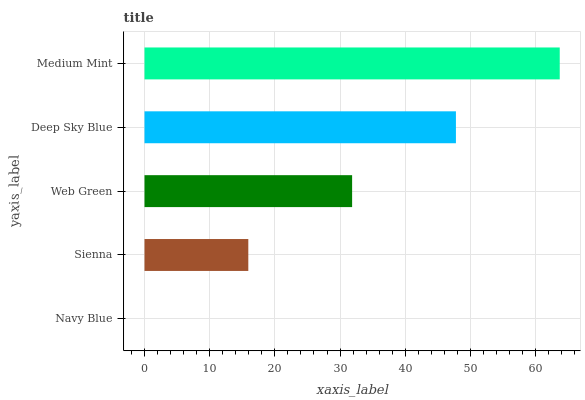Is Navy Blue the minimum?
Answer yes or no. Yes. Is Medium Mint the maximum?
Answer yes or no. Yes. Is Sienna the minimum?
Answer yes or no. No. Is Sienna the maximum?
Answer yes or no. No. Is Sienna greater than Navy Blue?
Answer yes or no. Yes. Is Navy Blue less than Sienna?
Answer yes or no. Yes. Is Navy Blue greater than Sienna?
Answer yes or no. No. Is Sienna less than Navy Blue?
Answer yes or no. No. Is Web Green the high median?
Answer yes or no. Yes. Is Web Green the low median?
Answer yes or no. Yes. Is Sienna the high median?
Answer yes or no. No. Is Navy Blue the low median?
Answer yes or no. No. 